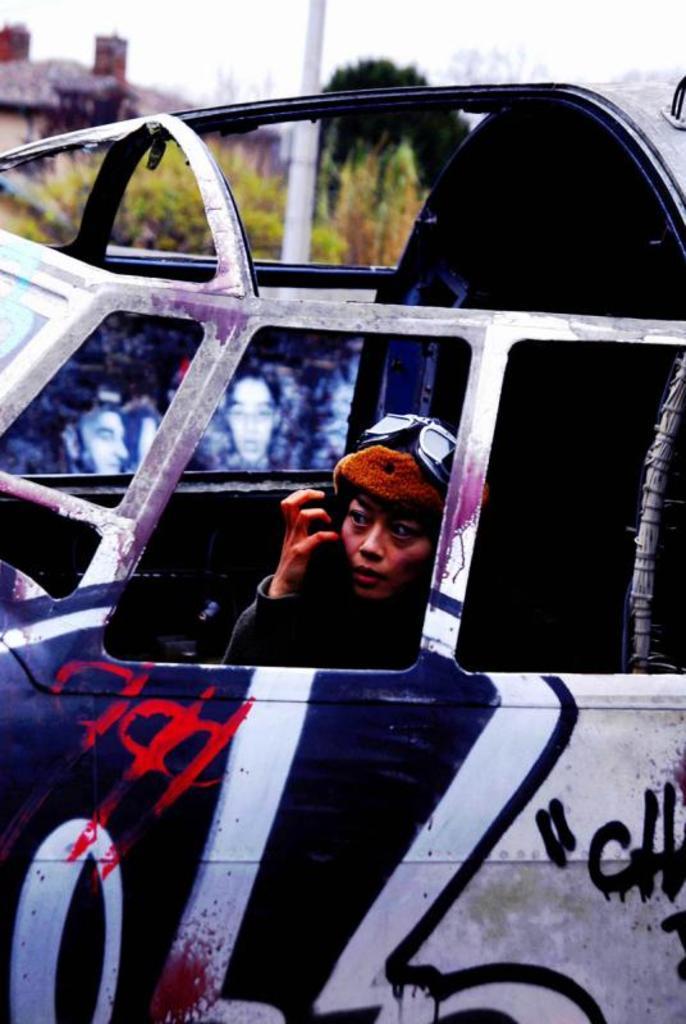Could you give a brief overview of what you see in this image? In this picture we can observe a woman sitting in the vehicle, wearing spectacles on her head. We can observe blue and red color on this white color vehicle. In the background there is a pole, trees and a sky. 